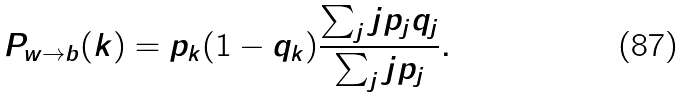Convert formula to latex. <formula><loc_0><loc_0><loc_500><loc_500>P _ { w \to b } ( k ) = p _ { k } ( 1 - q _ { k } ) \frac { \sum _ { j } j p _ { j } q _ { j } } { \sum _ { j } j p _ { j } } .</formula> 